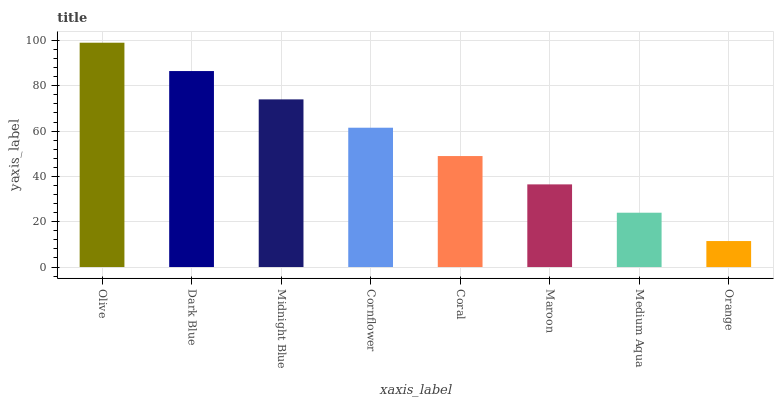Is Orange the minimum?
Answer yes or no. Yes. Is Olive the maximum?
Answer yes or no. Yes. Is Dark Blue the minimum?
Answer yes or no. No. Is Dark Blue the maximum?
Answer yes or no. No. Is Olive greater than Dark Blue?
Answer yes or no. Yes. Is Dark Blue less than Olive?
Answer yes or no. Yes. Is Dark Blue greater than Olive?
Answer yes or no. No. Is Olive less than Dark Blue?
Answer yes or no. No. Is Cornflower the high median?
Answer yes or no. Yes. Is Coral the low median?
Answer yes or no. Yes. Is Medium Aqua the high median?
Answer yes or no. No. Is Dark Blue the low median?
Answer yes or no. No. 